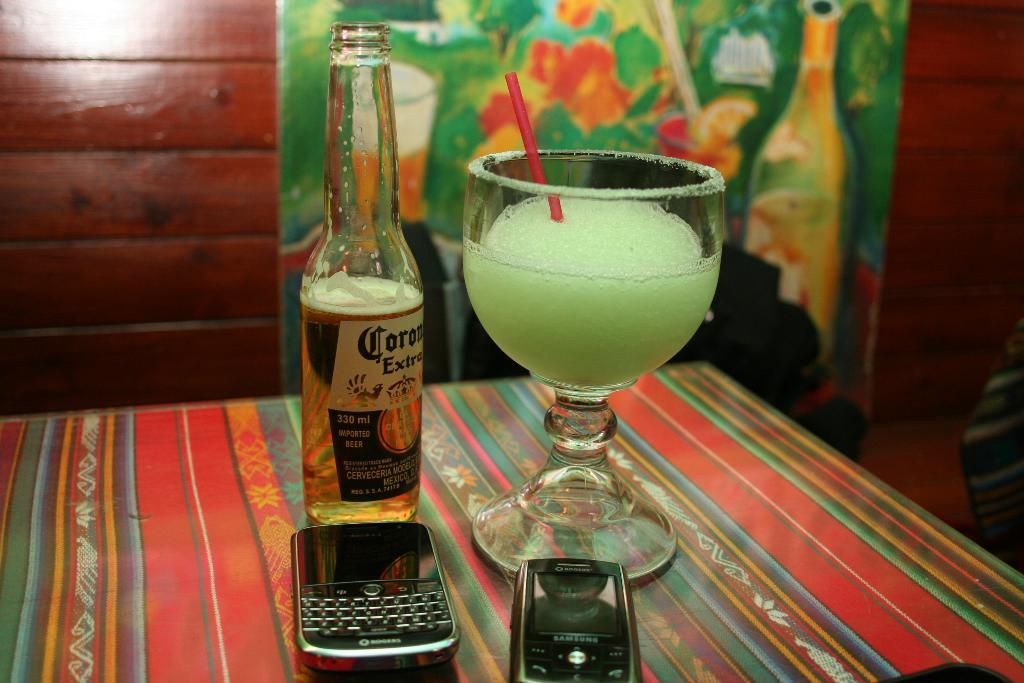<image>
Create a compact narrative representing the image presented. A bottle of Corona Extra sits next to a frozen drink in a goblet and a pair of cellphones on a striped table cloth. 